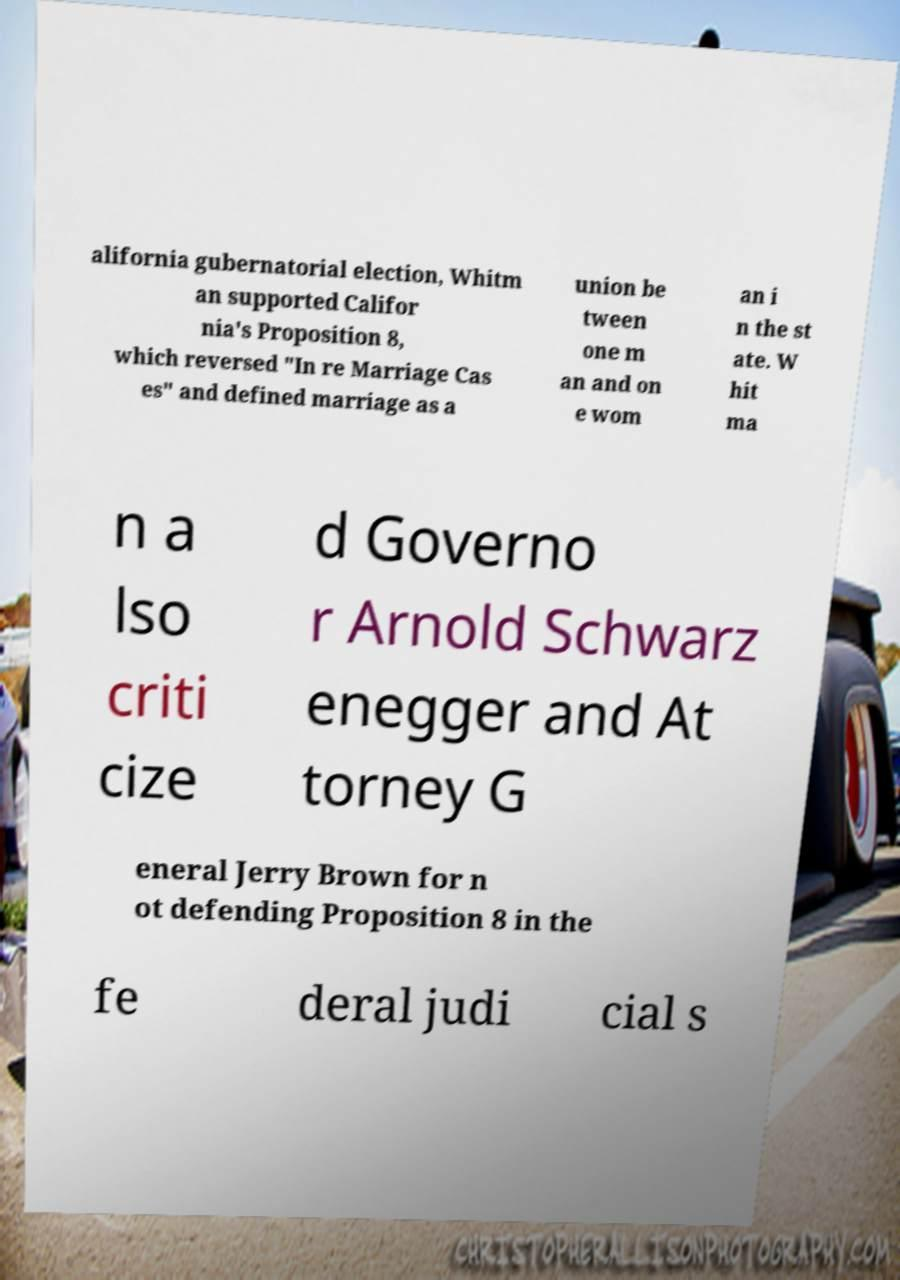Could you extract and type out the text from this image? alifornia gubernatorial election, Whitm an supported Califor nia's Proposition 8, which reversed "In re Marriage Cas es" and defined marriage as a union be tween one m an and on e wom an i n the st ate. W hit ma n a lso criti cize d Governo r Arnold Schwarz enegger and At torney G eneral Jerry Brown for n ot defending Proposition 8 in the fe deral judi cial s 